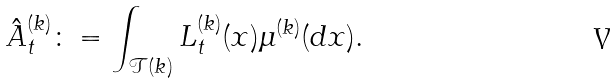Convert formula to latex. <formula><loc_0><loc_0><loc_500><loc_500>\hat { A } ^ { ( k ) } _ { t } \colon = \int _ { \mathcal { T } ( k ) } L ^ { ( k ) } _ { t } ( x ) \mu ^ { ( k ) } ( d x ) .</formula> 